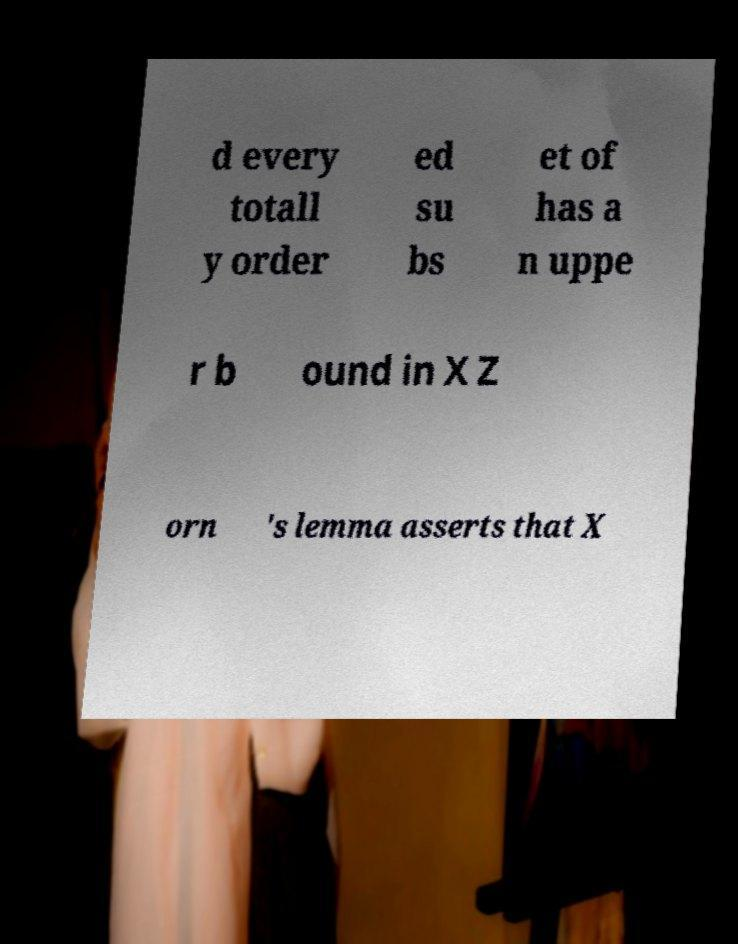Please read and relay the text visible in this image. What does it say? d every totall y order ed su bs et of has a n uppe r b ound in X Z orn 's lemma asserts that X 